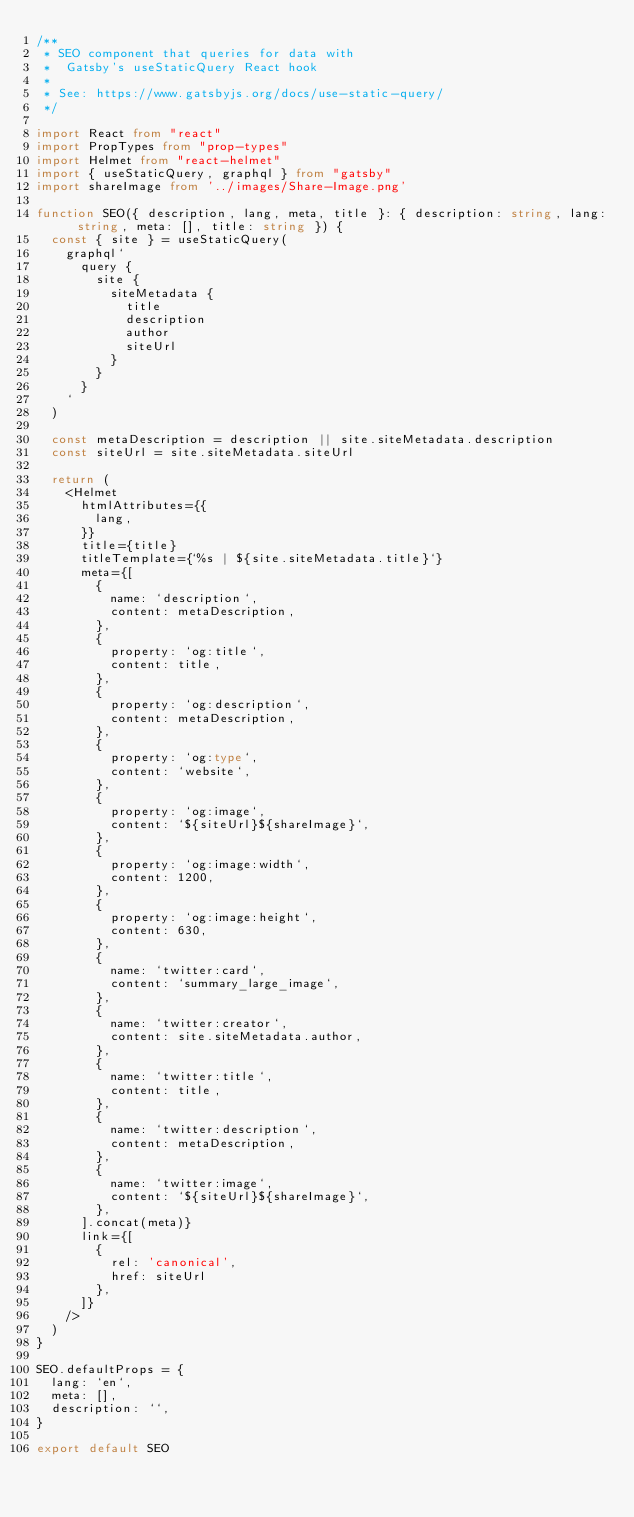Convert code to text. <code><loc_0><loc_0><loc_500><loc_500><_TypeScript_>/**
 * SEO component that queries for data with
 *  Gatsby's useStaticQuery React hook
 *
 * See: https://www.gatsbyjs.org/docs/use-static-query/
 */

import React from "react"
import PropTypes from "prop-types"
import Helmet from "react-helmet"
import { useStaticQuery, graphql } from "gatsby"
import shareImage from '../images/Share-Image.png'

function SEO({ description, lang, meta, title }: { description: string, lang: string, meta: [], title: string }) {
  const { site } = useStaticQuery(
    graphql`
      query {
        site {
          siteMetadata {
            title
            description
            author
            siteUrl
          }
        }
      }
    `
  )

  const metaDescription = description || site.siteMetadata.description
  const siteUrl = site.siteMetadata.siteUrl

  return (
    <Helmet
      htmlAttributes={{
        lang,
      }}
      title={title}
      titleTemplate={`%s | ${site.siteMetadata.title}`}
      meta={[
        {
          name: `description`,
          content: metaDescription,
        },
        {
          property: `og:title`,
          content: title,
        },
        {
          property: `og:description`,
          content: metaDescription,
        },
        {
          property: `og:type`,
          content: `website`,
        },
        {
          property: `og:image`,
          content: `${siteUrl}${shareImage}`,
        },
        {
          property: `og:image:width`,
          content: 1200,
        },
        {
          property: `og:image:height`,
          content: 630,
        },
        {
          name: `twitter:card`,
          content: `summary_large_image`,
        },
        {
          name: `twitter:creator`,
          content: site.siteMetadata.author,
        },
        {
          name: `twitter:title`,
          content: title,
        },
        {
          name: `twitter:description`,
          content: metaDescription,
        },
        {
          name: `twitter:image`,
          content: `${siteUrl}${shareImage}`,
        },
      ].concat(meta)}
      link={[
        {
          rel: 'canonical',
          href: siteUrl
        },
      ]}
    />
  )
}

SEO.defaultProps = {
  lang: `en`,
  meta: [],
  description: ``,
}

export default SEO
</code> 